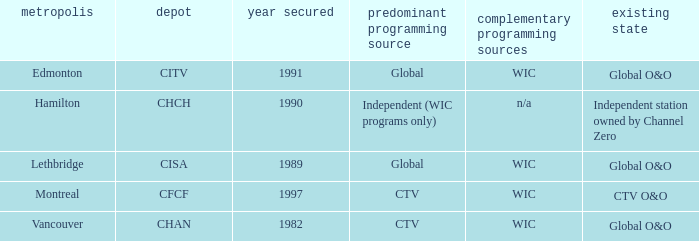How any were gained as the chan 1.0. 